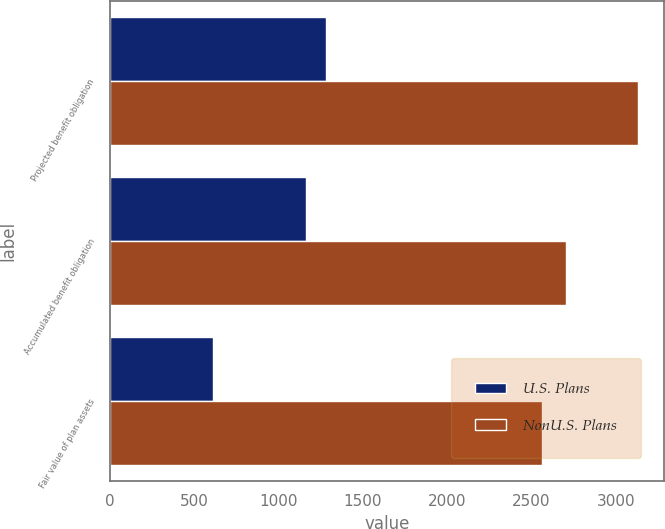Convert chart. <chart><loc_0><loc_0><loc_500><loc_500><stacked_bar_chart><ecel><fcel>Projected benefit obligation<fcel>Accumulated benefit obligation<fcel>Fair value of plan assets<nl><fcel>U.S. Plans<fcel>1284<fcel>1163<fcel>610<nl><fcel>NonU.S. Plans<fcel>3130<fcel>2704<fcel>2561<nl></chart> 